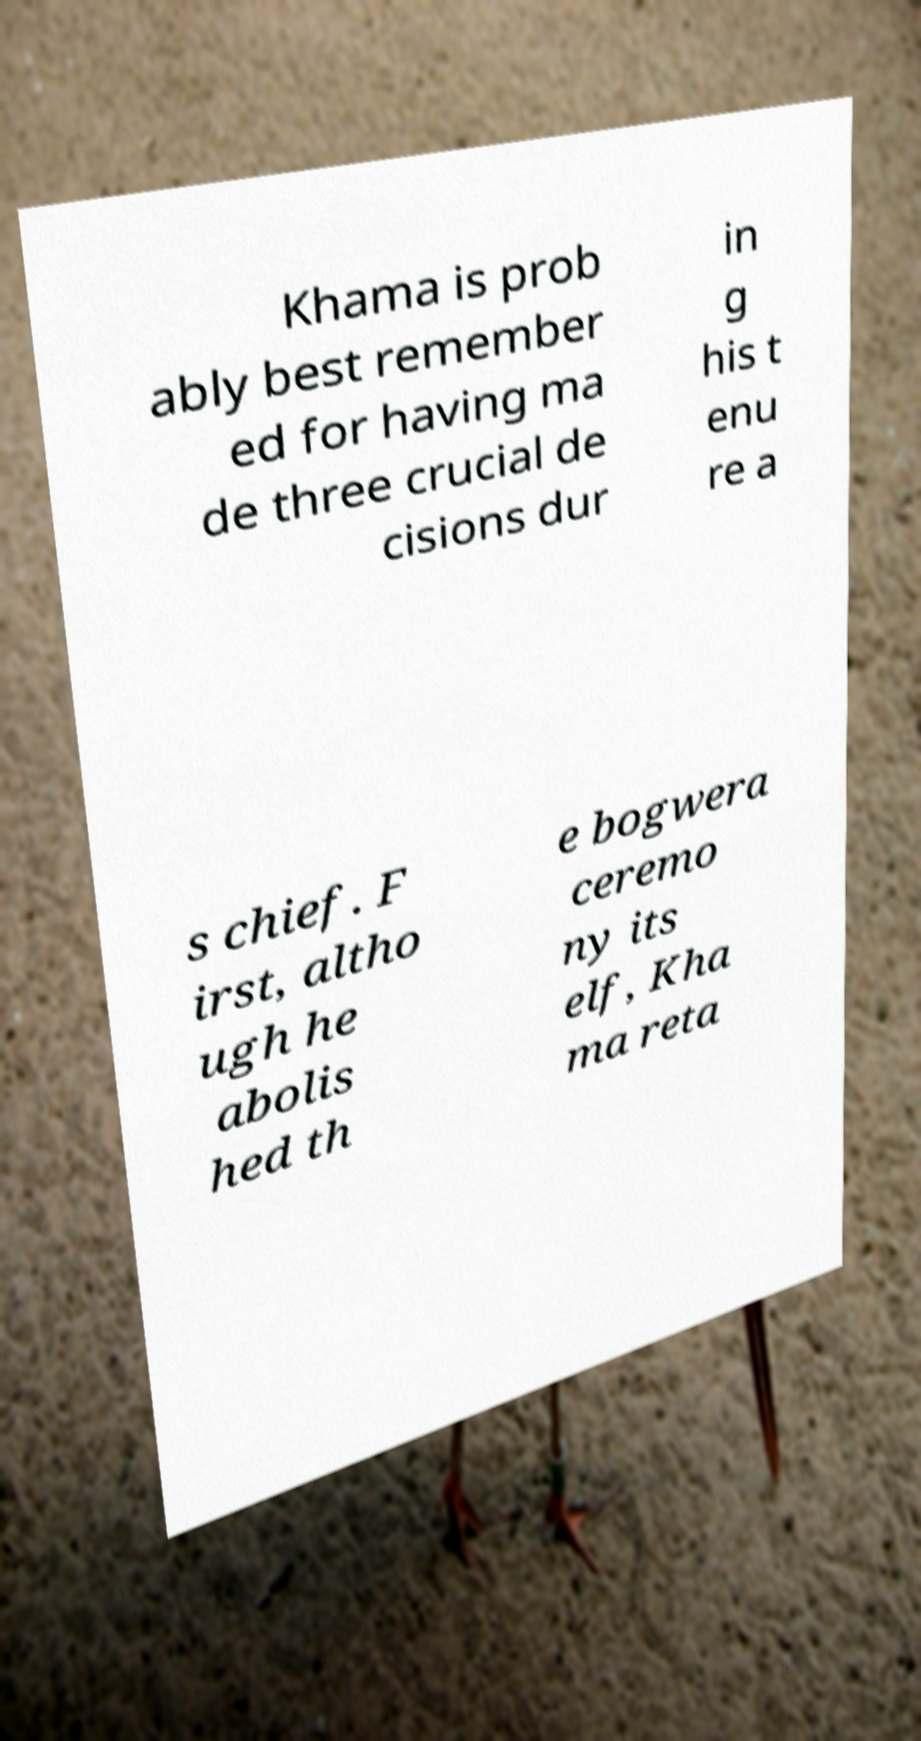Could you extract and type out the text from this image? Khama is prob ably best remember ed for having ma de three crucial de cisions dur in g his t enu re a s chief. F irst, altho ugh he abolis hed th e bogwera ceremo ny its elf, Kha ma reta 